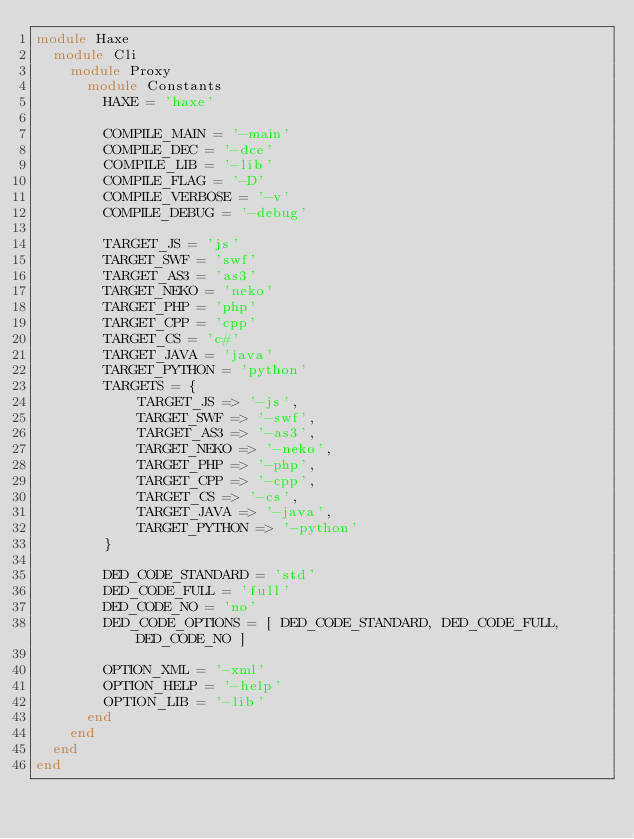Convert code to text. <code><loc_0><loc_0><loc_500><loc_500><_Ruby_>module Haxe
  module Cli
    module Proxy
      module Constants
        HAXE = 'haxe'

        COMPILE_MAIN = '-main'
        COMPILE_DEC = '-dce'
        COMPILE_LIB = '-lib'
        COMPILE_FLAG = '-D'
        COMPILE_VERBOSE = '-v'
        COMPILE_DEBUG = '-debug'

        TARGET_JS = 'js'
        TARGET_SWF = 'swf'
        TARGET_AS3 = 'as3'
        TARGET_NEKO = 'neko'
        TARGET_PHP = 'php'
        TARGET_CPP = 'cpp'
        TARGET_CS = 'c#'
        TARGET_JAVA = 'java'
        TARGET_PYTHON = 'python'
        TARGETS = {
            TARGET_JS => '-js',
            TARGET_SWF => '-swf',
            TARGET_AS3 => '-as3',
            TARGET_NEKO => '-neko',
            TARGET_PHP => '-php',
            TARGET_CPP => '-cpp',
            TARGET_CS => '-cs',
            TARGET_JAVA => '-java',
            TARGET_PYTHON => '-python'
        }

        DED_CODE_STANDARD = 'std'
        DED_CODE_FULL = 'full'
        DED_CODE_NO = 'no'
        DED_CODE_OPTIONS = [ DED_CODE_STANDARD, DED_CODE_FULL, DED_CODE_NO ]

        OPTION_XML = '-xml'
        OPTION_HELP = '-help'
        OPTION_LIB = '-lib'
      end
    end
  end
end</code> 